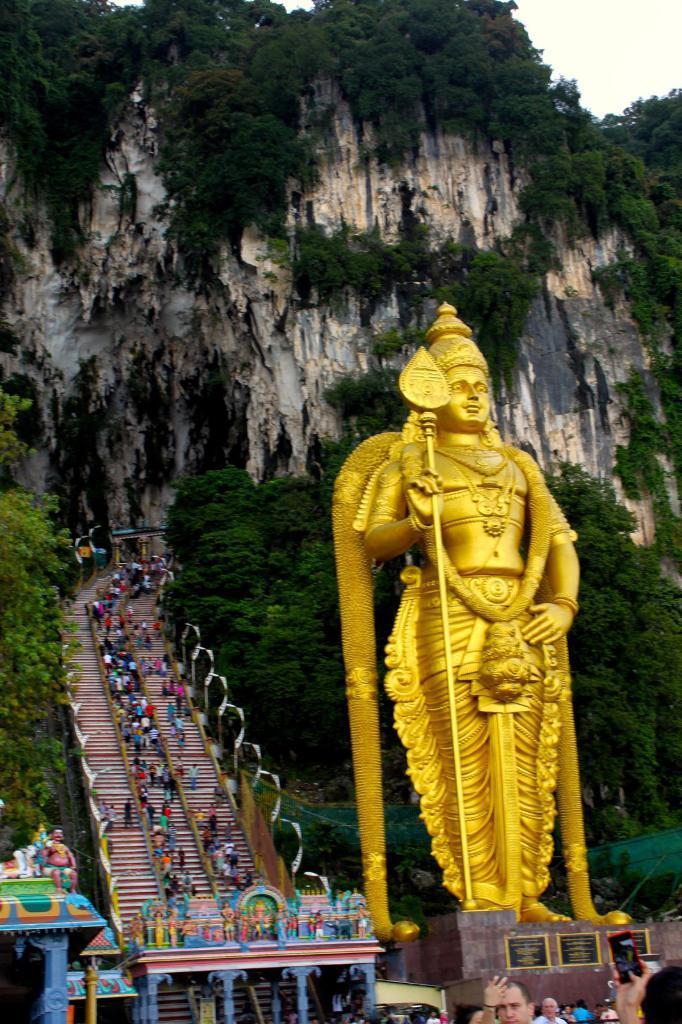Describe this image in one or two sentences. There is a statue with a golden color on a stand. In the back there is a entrance with some statues. In the background there are steps with railings. On that there are many people. Also there are trees and rock hill in the background. 